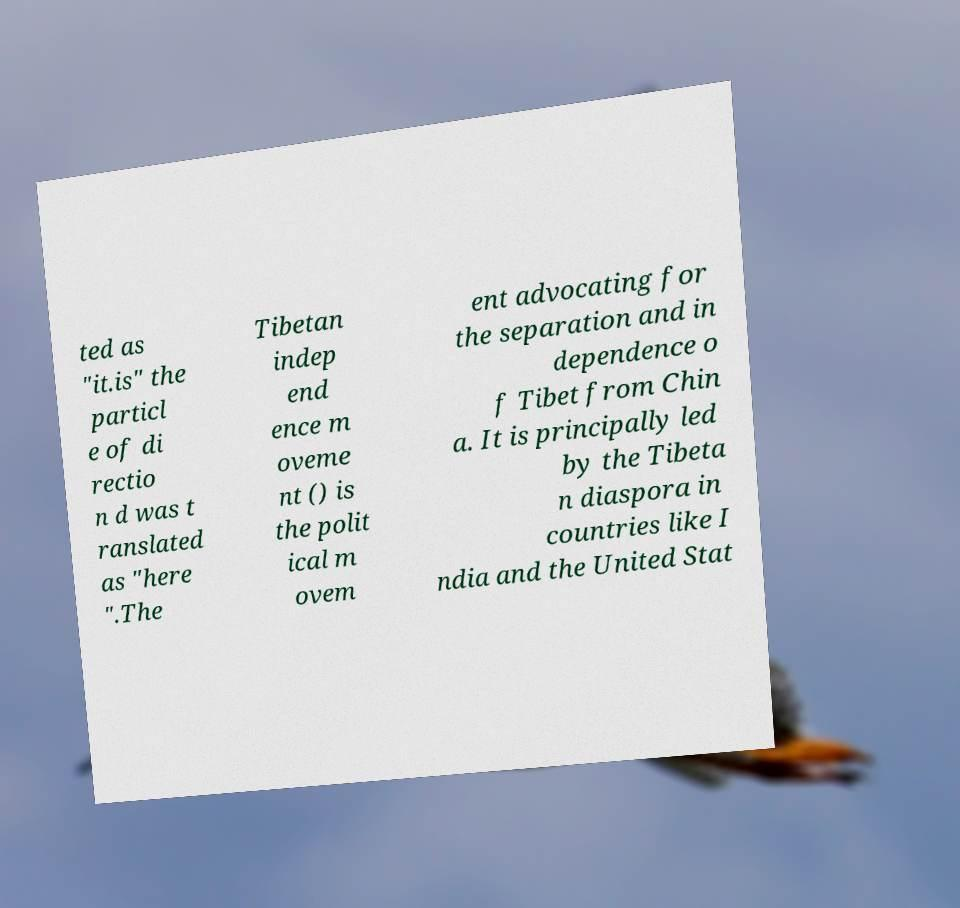I need the written content from this picture converted into text. Can you do that? ted as "it.is" the particl e of di rectio n d was t ranslated as "here ".The Tibetan indep end ence m oveme nt () is the polit ical m ovem ent advocating for the separation and in dependence o f Tibet from Chin a. It is principally led by the Tibeta n diaspora in countries like I ndia and the United Stat 